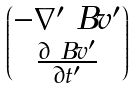<formula> <loc_0><loc_0><loc_500><loc_500>\begin{pmatrix} - \nabla ^ { \prime } \ B v ^ { \prime } \\ \frac { \partial \ B v ^ { \prime } } { \partial t ^ { \prime } } \end{pmatrix}</formula> 